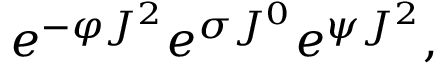<formula> <loc_0><loc_0><loc_500><loc_500>e ^ { - \varphi J ^ { 2 } } e ^ { \sigma J ^ { 0 } } e ^ { \psi J ^ { 2 } } ,</formula> 